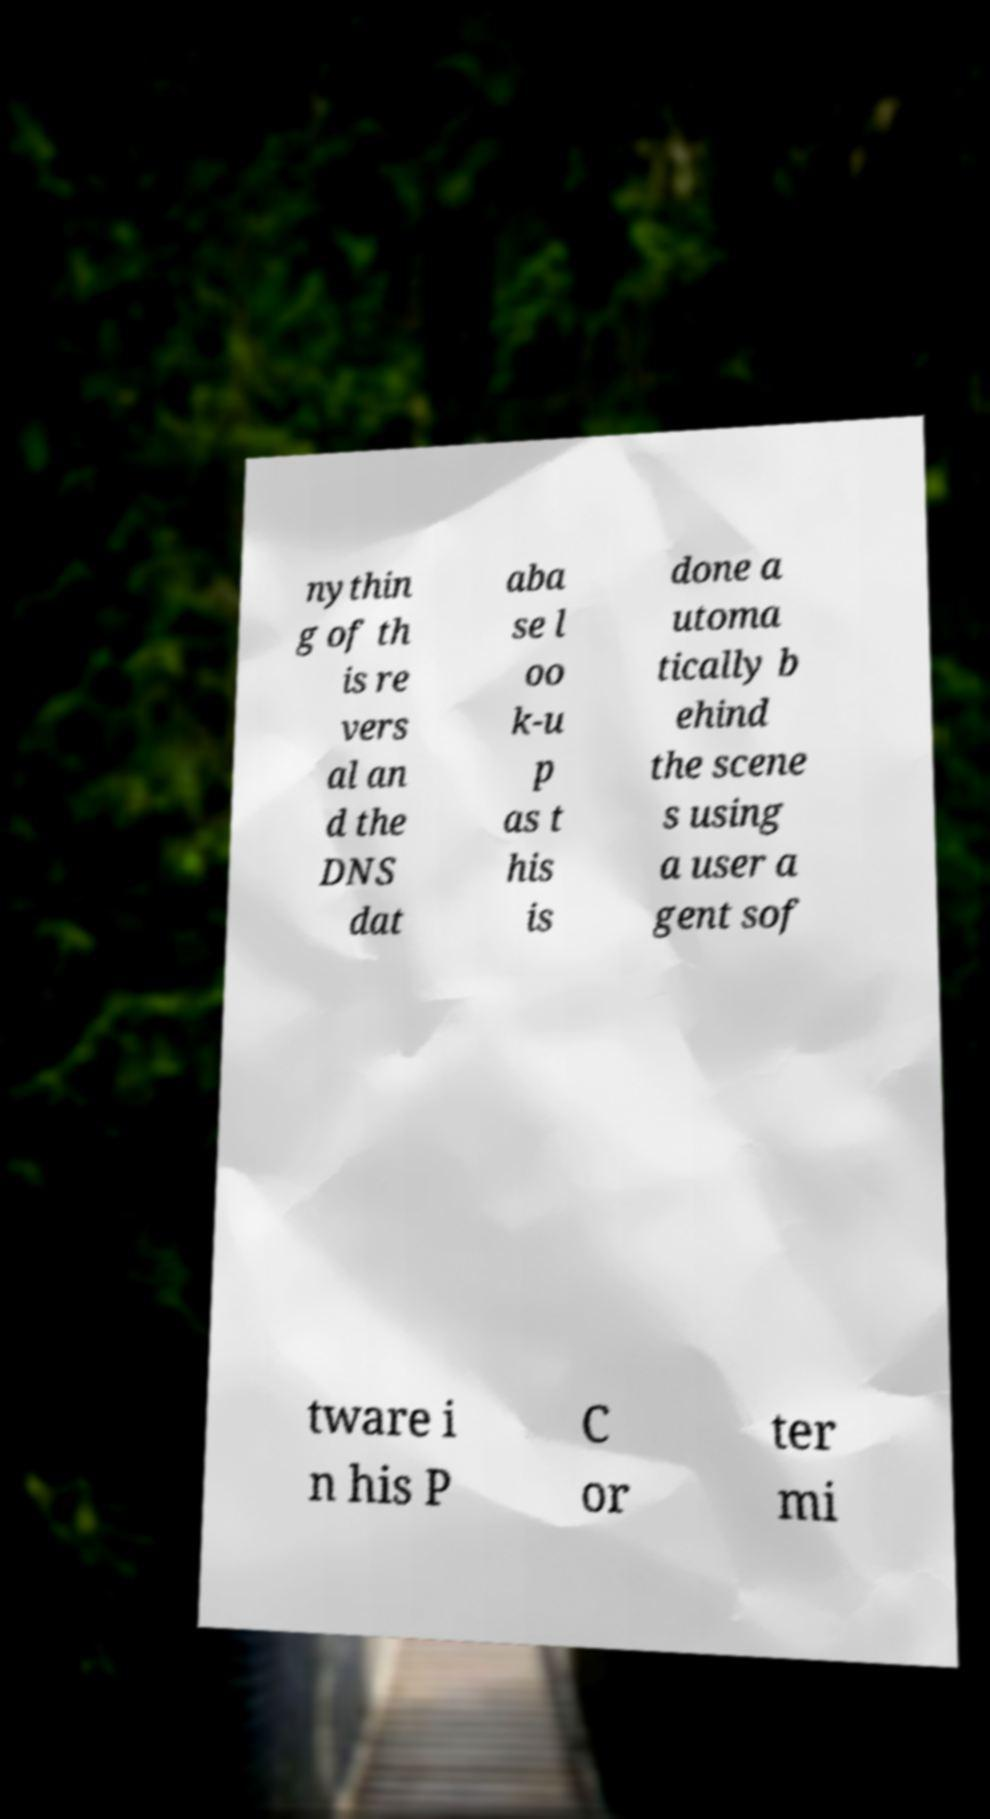What messages or text are displayed in this image? I need them in a readable, typed format. nythin g of th is re vers al an d the DNS dat aba se l oo k-u p as t his is done a utoma tically b ehind the scene s using a user a gent sof tware i n his P C or ter mi 